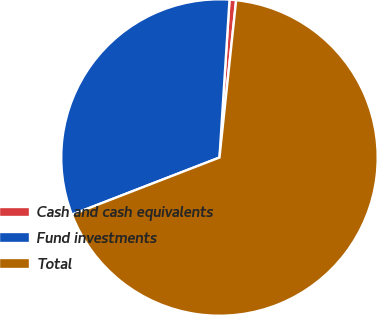Convert chart. <chart><loc_0><loc_0><loc_500><loc_500><pie_chart><fcel>Cash and cash equivalents<fcel>Fund investments<fcel>Total<nl><fcel>0.67%<fcel>31.89%<fcel>67.43%<nl></chart> 